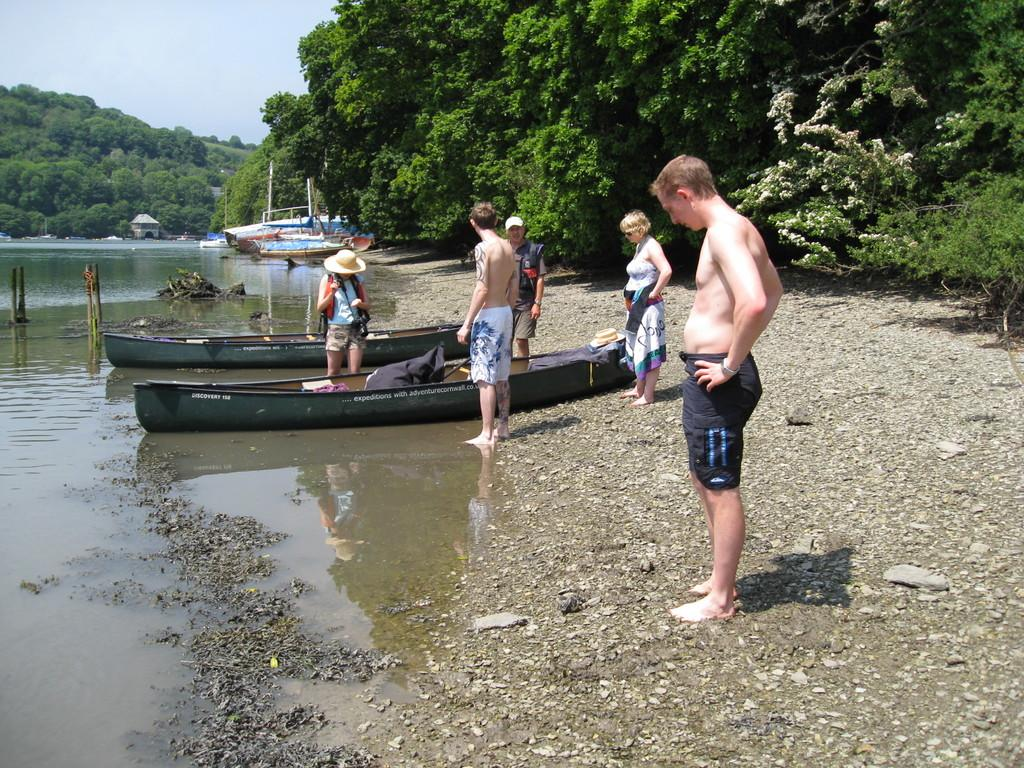What can be seen in the image involving people? There are people standing in the image. What is on the water in the image? There are boats on the water in the image. What type of vegetation is visible in the background of the image? Trees are visible in the background of the image. What is the color of the trees in the image? The trees are green in color. What is visible in the sky in the image? The sky is visible in the image, and it has both white and blue colors. Where is the yak located in the image? There is no yak present in the image. What type of door can be seen in the image? There is no door present in the image. 